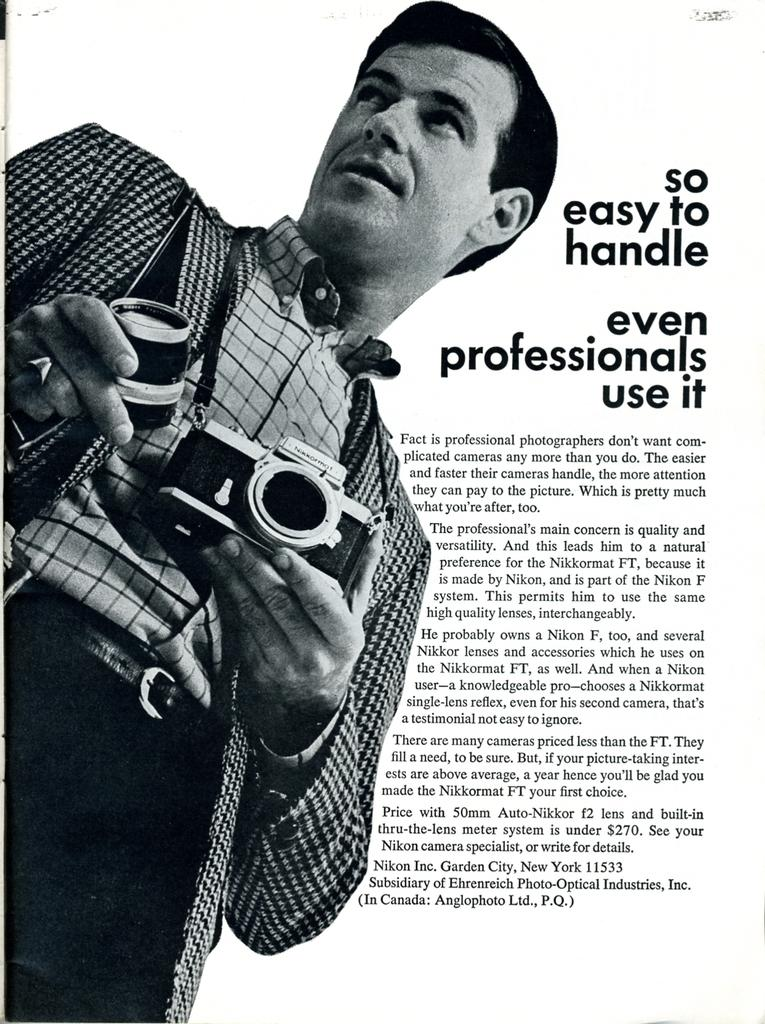What type of image is being described? The image is a poster. Who or what is depicted in the poster? There is a man in the poster. What is the man holding in the poster? The man is holding an object, which appears to be a camera. Is there any text present on the poster? Yes, there is text on the poster. Can you hear the man in the poster crying in the image? There is no sound in the image, and the man is not depicted as crying. 